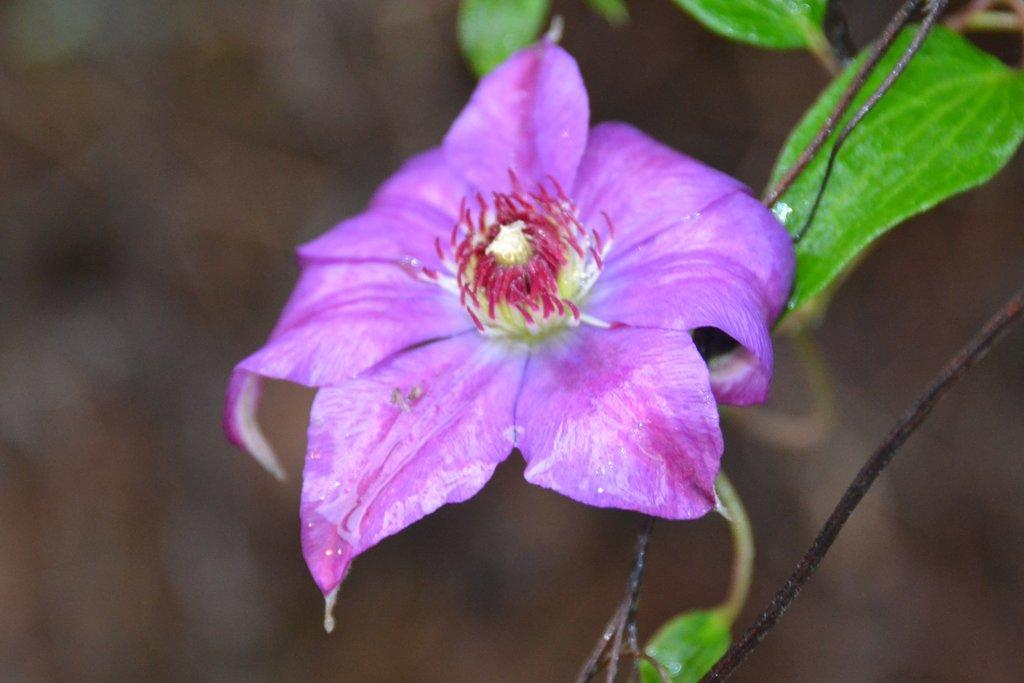What type of flower can be seen in the image? There is a purple color flower in the image. What color are the leaves in the image? There are green leaves in the image. Can you see a ticket attached to the flower in the image? There is no ticket present in the image; it only features a purple flower and green leaves. 